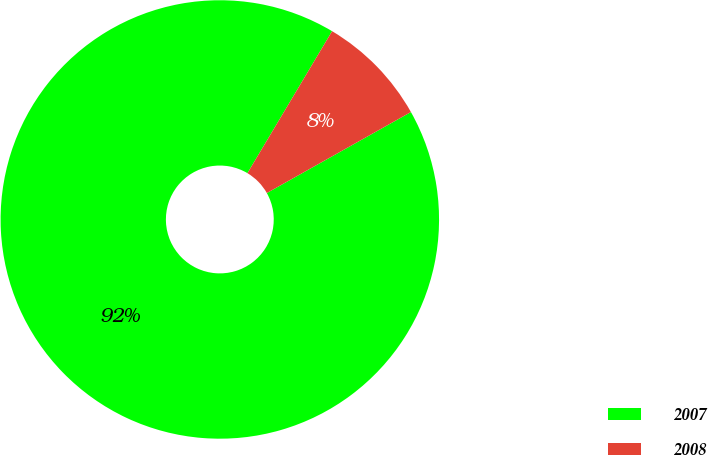Convert chart to OTSL. <chart><loc_0><loc_0><loc_500><loc_500><pie_chart><fcel>2007<fcel>2008<nl><fcel>91.71%<fcel>8.29%<nl></chart> 